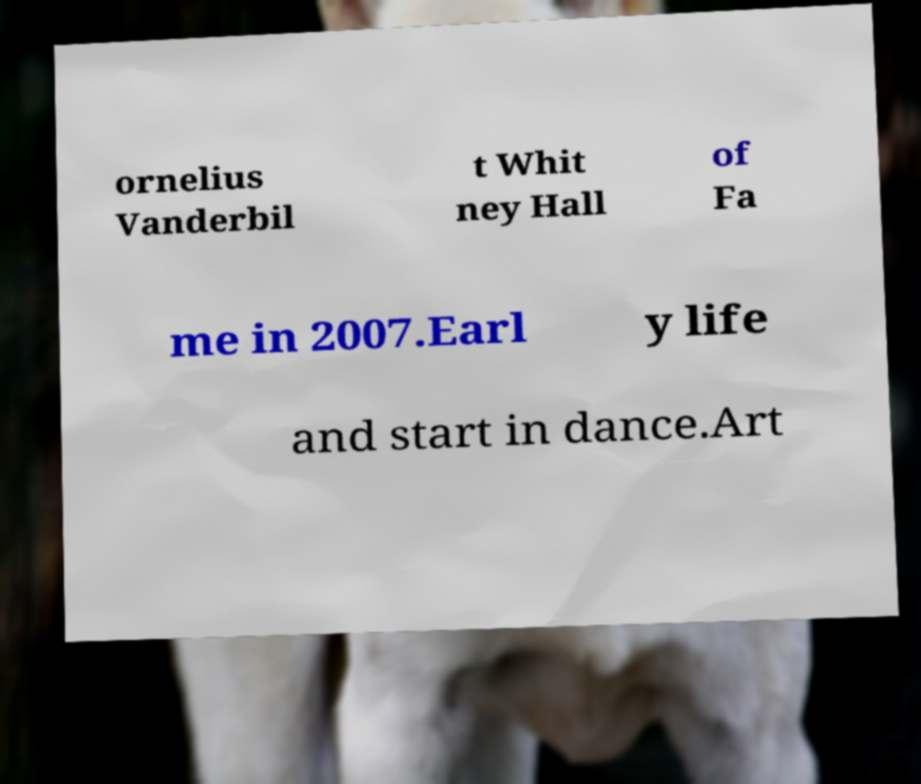Could you extract and type out the text from this image? ornelius Vanderbil t Whit ney Hall of Fa me in 2007.Earl y life and start in dance.Art 